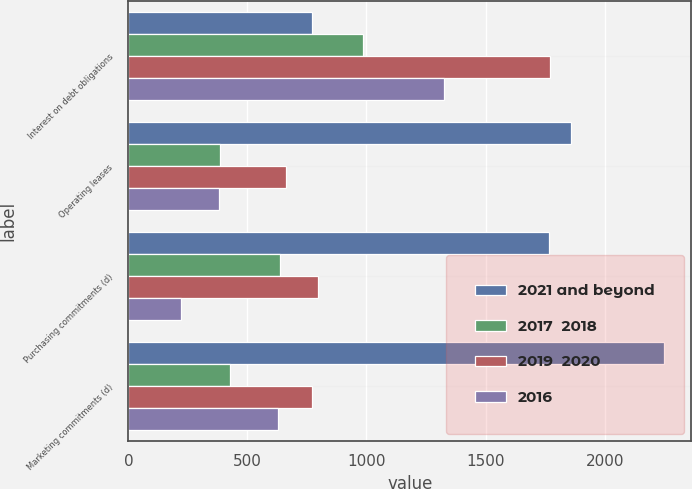<chart> <loc_0><loc_0><loc_500><loc_500><stacked_bar_chart><ecel><fcel>Interest on debt obligations<fcel>Operating leases<fcel>Purchasing commitments (d)<fcel>Marketing commitments (d)<nl><fcel>2021 and beyond<fcel>773<fcel>1860<fcel>1767<fcel>2251<nl><fcel>2017  2018<fcel>987<fcel>387<fcel>635<fcel>428<nl><fcel>2019  2020<fcel>1770<fcel>660<fcel>798<fcel>773<nl><fcel>2016<fcel>1325<fcel>380<fcel>220<fcel>627<nl></chart> 